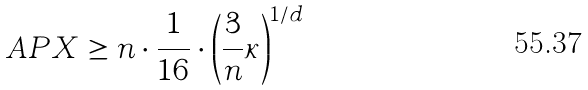Convert formula to latex. <formula><loc_0><loc_0><loc_500><loc_500>A P X \geq n \cdot \frac { 1 } { 1 6 } \cdot \left ( \frac { 3 } { n } \kappa \right ) ^ { 1 / d }</formula> 